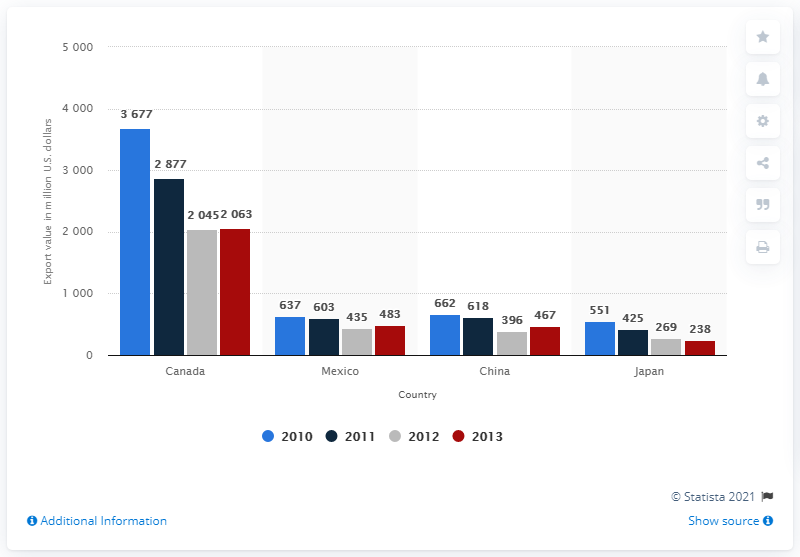Outline some significant characteristics in this image. The export of soap and cleaning products from the United States to Canada in 2012 was valued at 2045. 